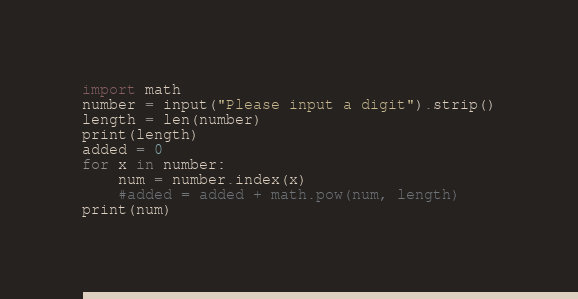Convert code to text. <code><loc_0><loc_0><loc_500><loc_500><_Python_>import math
number = input("Please input a digit").strip()
length = len(number)
print(length)
added = 0
for x in number:
    num = number.index(x)
    #added = added + math.pow(num, length)
print(num)</code> 